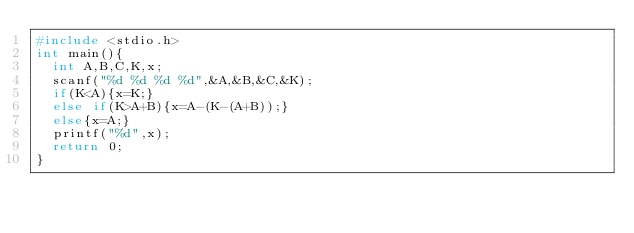Convert code to text. <code><loc_0><loc_0><loc_500><loc_500><_C_>#include <stdio.h>
int main(){
  int A,B,C,K,x;
  scanf("%d %d %d %d",&A,&B,&C,&K);
  if(K<A){x=K;}
  else if(K>A+B){x=A-(K-(A+B));}
  else{x=A;}
  printf("%d",x);
  return 0;
}</code> 